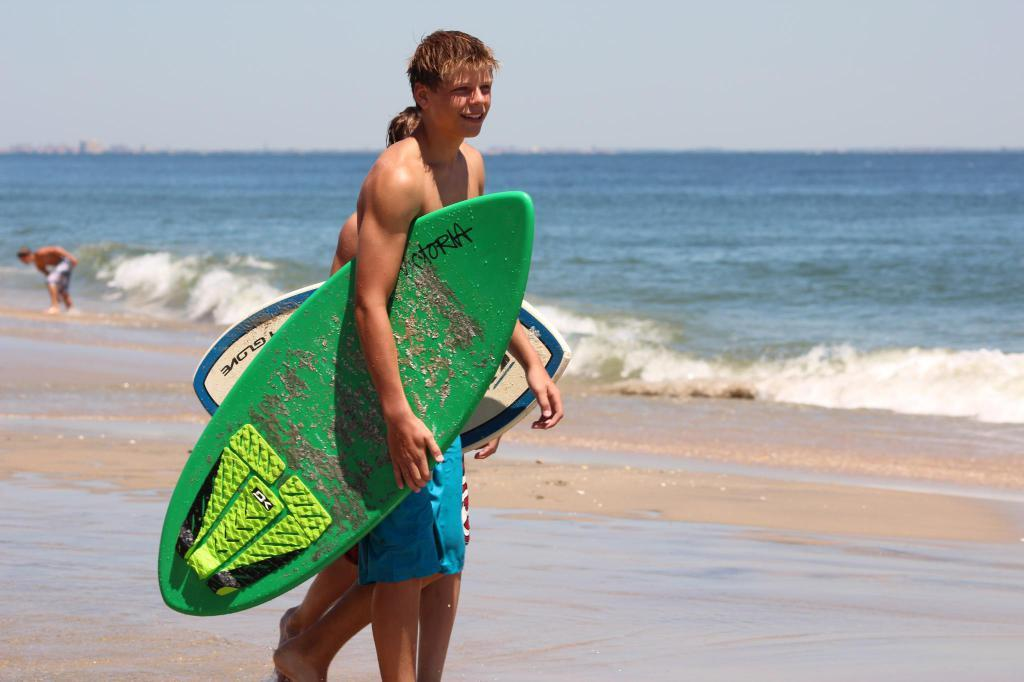Who or what is present in the image? There are people in the image. What are the people holding in the image? The people are holding surfing boards. What type of environment can be seen in the image? There is an ocean visible in the image. What type of pencil can be seen in the image? There is no pencil present in the image. What flavor of jam is being spread on the surfing boards in the image? There is no jam present in the image, and the surfing boards are not being used for spreading jam. 